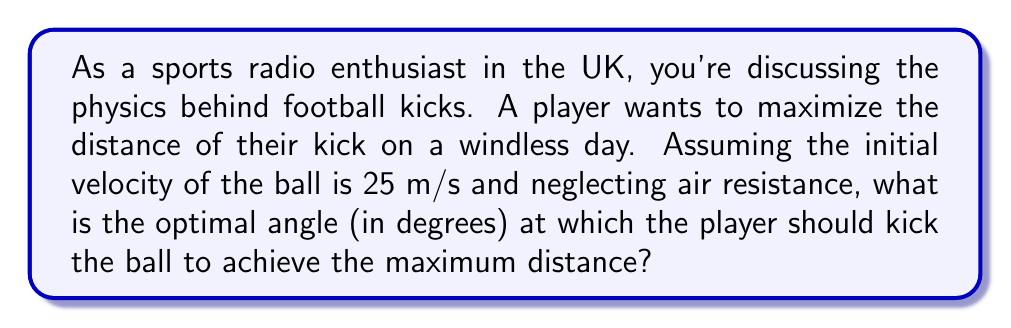Provide a solution to this math problem. To solve this problem, we need to use the principles of projectile motion. The range (R) of a projectile launched from ground level is given by the formula:

$$ R = \frac{v^2 \sin(2\theta)}{g} $$

Where:
- $v$ is the initial velocity
- $\theta$ is the launch angle
- $g$ is the acceleration due to gravity (approximately 9.8 m/s²)

To find the maximum range, we need to maximize $\sin(2\theta)$. The sine function reaches its maximum value of 1 when its argument is 90°. Therefore:

$$ 2\theta = 90° $$
$$ \theta = 45° $$

This result is independent of the initial velocity and the acceleration due to gravity. It holds true for any projectile motion in a uniform gravitational field, neglecting air resistance.

To verify, we can calculate the range for the given initial velocity:

$$ R = \frac{(25 \text{ m/s})^2 \sin(2 \cdot 45°)}{9.8 \text{ m/s}^2} $$
$$ R = \frac{625 \text{ m}^2/\text{s}^2 \cdot 1}{9.8 \text{ m/s}^2} $$
$$ R \approx 63.78 \text{ m} $$

This is indeed the maximum range for the given initial velocity.
Answer: The optimal angle for the football kick to maximize distance is 45°. 